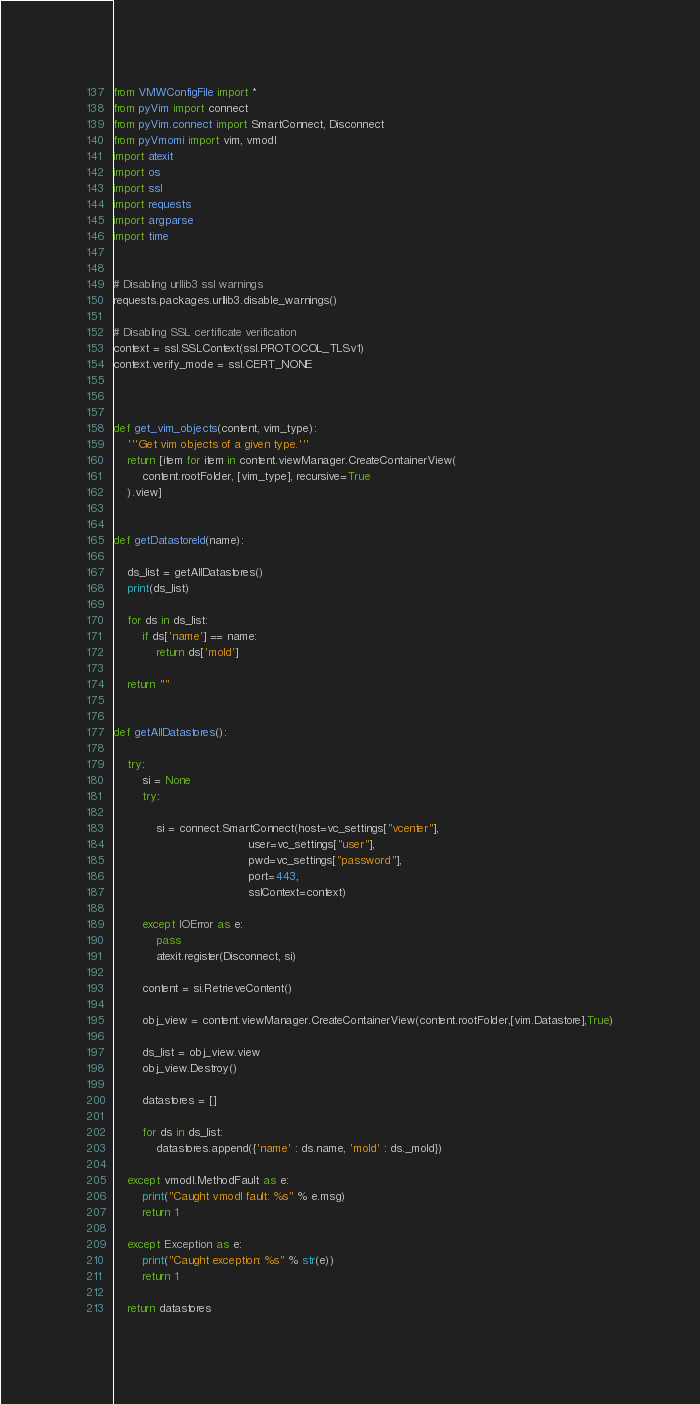Convert code to text. <code><loc_0><loc_0><loc_500><loc_500><_Python_>from VMWConfigFile import *
from pyVim import connect
from pyVim.connect import SmartConnect, Disconnect
from pyVmomi import vim, vmodl
import atexit
import os
import ssl
import requests
import argparse
import time


# Disabling urllib3 ssl warnings
requests.packages.urllib3.disable_warnings()
 
# Disabling SSL certificate verification
context = ssl.SSLContext(ssl.PROTOCOL_TLSv1)
context.verify_mode = ssl.CERT_NONE



def get_vim_objects(content, vim_type):
    '''Get vim objects of a given type.'''
    return [item for item in content.viewManager.CreateContainerView(
        content.rootFolder, [vim_type], recursive=True
    ).view]


def getDatastoreId(name):

    ds_list = getAllDatastores()
    print(ds_list)

    for ds in ds_list:
        if ds['name'] == name:
            return ds['moId']

    return ""


def getAllDatastores():

    try:
        si = None
        try:
            
            si = connect.SmartConnect(host=vc_settings["vcenter"],
                                      user=vc_settings["user"],
                                      pwd=vc_settings["password"],
                                      port=443,
                                      sslContext=context)

        except IOError as e:
            pass
            atexit.register(Disconnect, si)

        content = si.RetrieveContent()

        obj_view = content.viewManager.CreateContainerView(content.rootFolder,[vim.Datastore],True)

        ds_list = obj_view.view
        obj_view.Destroy()

        datastores = []

        for ds in ds_list:
            datastores.append({'name' : ds.name, 'moId' : ds._moId})
        
    except vmodl.MethodFault as e:
        print("Caught vmodl fault: %s" % e.msg)
        return 1

    except Exception as e:
        print("Caught exception: %s" % str(e))
        return 1

    return datastores</code> 